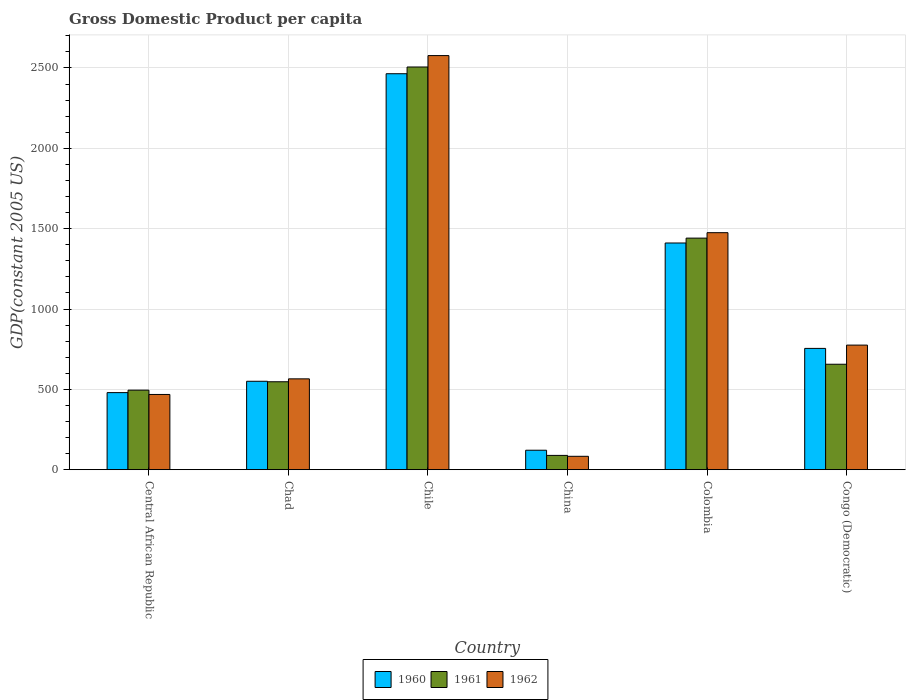How many different coloured bars are there?
Provide a succinct answer. 3. How many groups of bars are there?
Ensure brevity in your answer.  6. Are the number of bars per tick equal to the number of legend labels?
Provide a short and direct response. Yes. What is the GDP per capita in 1962 in Chad?
Offer a terse response. 565.29. Across all countries, what is the maximum GDP per capita in 1962?
Ensure brevity in your answer.  2577.05. Across all countries, what is the minimum GDP per capita in 1962?
Provide a short and direct response. 83.33. In which country was the GDP per capita in 1960 minimum?
Your response must be concise. China. What is the total GDP per capita in 1962 in the graph?
Your answer should be compact. 5944.15. What is the difference between the GDP per capita in 1960 in Central African Republic and that in Chad?
Give a very brief answer. -70.54. What is the difference between the GDP per capita in 1961 in Congo (Democratic) and the GDP per capita in 1960 in Central African Republic?
Provide a short and direct response. 176.5. What is the average GDP per capita in 1962 per country?
Keep it short and to the point. 990.69. What is the difference between the GDP per capita of/in 1960 and GDP per capita of/in 1962 in Chile?
Provide a succinct answer. -112.9. What is the ratio of the GDP per capita in 1961 in Central African Republic to that in China?
Provide a short and direct response. 5.56. Is the difference between the GDP per capita in 1960 in Chad and Chile greater than the difference between the GDP per capita in 1962 in Chad and Chile?
Your answer should be compact. Yes. What is the difference between the highest and the second highest GDP per capita in 1962?
Offer a very short reply. 1102.11. What is the difference between the highest and the lowest GDP per capita in 1962?
Give a very brief answer. 2493.72. In how many countries, is the GDP per capita in 1960 greater than the average GDP per capita in 1960 taken over all countries?
Offer a terse response. 2. How many bars are there?
Offer a terse response. 18. What is the difference between two consecutive major ticks on the Y-axis?
Provide a succinct answer. 500. Are the values on the major ticks of Y-axis written in scientific E-notation?
Give a very brief answer. No. How are the legend labels stacked?
Keep it short and to the point. Horizontal. What is the title of the graph?
Give a very brief answer. Gross Domestic Product per capita. Does "1989" appear as one of the legend labels in the graph?
Your answer should be compact. No. What is the label or title of the Y-axis?
Your answer should be compact. GDP(constant 2005 US). What is the GDP(constant 2005 US) in 1960 in Central African Republic?
Provide a succinct answer. 479.7. What is the GDP(constant 2005 US) of 1961 in Central African Republic?
Your response must be concise. 494.99. What is the GDP(constant 2005 US) of 1962 in Central African Republic?
Give a very brief answer. 468.21. What is the GDP(constant 2005 US) in 1960 in Chad?
Provide a succinct answer. 550.24. What is the GDP(constant 2005 US) in 1961 in Chad?
Offer a terse response. 547.21. What is the GDP(constant 2005 US) in 1962 in Chad?
Make the answer very short. 565.29. What is the GDP(constant 2005 US) of 1960 in Chile?
Give a very brief answer. 2464.15. What is the GDP(constant 2005 US) in 1961 in Chile?
Offer a terse response. 2506.04. What is the GDP(constant 2005 US) of 1962 in Chile?
Ensure brevity in your answer.  2577.05. What is the GDP(constant 2005 US) of 1960 in China?
Give a very brief answer. 121.19. What is the GDP(constant 2005 US) in 1961 in China?
Keep it short and to the point. 89.01. What is the GDP(constant 2005 US) in 1962 in China?
Your answer should be compact. 83.33. What is the GDP(constant 2005 US) of 1960 in Colombia?
Give a very brief answer. 1410.75. What is the GDP(constant 2005 US) in 1961 in Colombia?
Offer a very short reply. 1441.14. What is the GDP(constant 2005 US) of 1962 in Colombia?
Offer a very short reply. 1474.94. What is the GDP(constant 2005 US) of 1960 in Congo (Democratic)?
Offer a very short reply. 754.88. What is the GDP(constant 2005 US) of 1961 in Congo (Democratic)?
Make the answer very short. 656.2. What is the GDP(constant 2005 US) in 1962 in Congo (Democratic)?
Offer a very short reply. 775.32. Across all countries, what is the maximum GDP(constant 2005 US) of 1960?
Provide a short and direct response. 2464.15. Across all countries, what is the maximum GDP(constant 2005 US) in 1961?
Provide a short and direct response. 2506.04. Across all countries, what is the maximum GDP(constant 2005 US) in 1962?
Provide a succinct answer. 2577.05. Across all countries, what is the minimum GDP(constant 2005 US) of 1960?
Your answer should be compact. 121.19. Across all countries, what is the minimum GDP(constant 2005 US) of 1961?
Ensure brevity in your answer.  89.01. Across all countries, what is the minimum GDP(constant 2005 US) of 1962?
Make the answer very short. 83.33. What is the total GDP(constant 2005 US) of 1960 in the graph?
Give a very brief answer. 5780.91. What is the total GDP(constant 2005 US) of 1961 in the graph?
Ensure brevity in your answer.  5734.6. What is the total GDP(constant 2005 US) in 1962 in the graph?
Offer a very short reply. 5944.15. What is the difference between the GDP(constant 2005 US) in 1960 in Central African Republic and that in Chad?
Your response must be concise. -70.54. What is the difference between the GDP(constant 2005 US) of 1961 in Central African Republic and that in Chad?
Ensure brevity in your answer.  -52.22. What is the difference between the GDP(constant 2005 US) in 1962 in Central African Republic and that in Chad?
Offer a very short reply. -97.08. What is the difference between the GDP(constant 2005 US) in 1960 in Central African Republic and that in Chile?
Offer a very short reply. -1984.45. What is the difference between the GDP(constant 2005 US) of 1961 in Central African Republic and that in Chile?
Your answer should be very brief. -2011.05. What is the difference between the GDP(constant 2005 US) in 1962 in Central African Republic and that in Chile?
Keep it short and to the point. -2108.84. What is the difference between the GDP(constant 2005 US) in 1960 in Central African Republic and that in China?
Your answer should be compact. 358.51. What is the difference between the GDP(constant 2005 US) of 1961 in Central African Republic and that in China?
Keep it short and to the point. 405.99. What is the difference between the GDP(constant 2005 US) of 1962 in Central African Republic and that in China?
Your answer should be compact. 384.88. What is the difference between the GDP(constant 2005 US) of 1960 in Central African Republic and that in Colombia?
Offer a very short reply. -931.05. What is the difference between the GDP(constant 2005 US) in 1961 in Central African Republic and that in Colombia?
Offer a very short reply. -946.15. What is the difference between the GDP(constant 2005 US) in 1962 in Central African Republic and that in Colombia?
Provide a short and direct response. -1006.73. What is the difference between the GDP(constant 2005 US) of 1960 in Central African Republic and that in Congo (Democratic)?
Ensure brevity in your answer.  -275.18. What is the difference between the GDP(constant 2005 US) in 1961 in Central African Republic and that in Congo (Democratic)?
Offer a very short reply. -161.21. What is the difference between the GDP(constant 2005 US) in 1962 in Central African Republic and that in Congo (Democratic)?
Offer a very short reply. -307.11. What is the difference between the GDP(constant 2005 US) of 1960 in Chad and that in Chile?
Your answer should be compact. -1913.91. What is the difference between the GDP(constant 2005 US) in 1961 in Chad and that in Chile?
Make the answer very short. -1958.84. What is the difference between the GDP(constant 2005 US) in 1962 in Chad and that in Chile?
Provide a succinct answer. -2011.76. What is the difference between the GDP(constant 2005 US) in 1960 in Chad and that in China?
Keep it short and to the point. 429.05. What is the difference between the GDP(constant 2005 US) of 1961 in Chad and that in China?
Your response must be concise. 458.2. What is the difference between the GDP(constant 2005 US) in 1962 in Chad and that in China?
Give a very brief answer. 481.95. What is the difference between the GDP(constant 2005 US) of 1960 in Chad and that in Colombia?
Your answer should be very brief. -860.51. What is the difference between the GDP(constant 2005 US) of 1961 in Chad and that in Colombia?
Your response must be concise. -893.93. What is the difference between the GDP(constant 2005 US) in 1962 in Chad and that in Colombia?
Your answer should be compact. -909.66. What is the difference between the GDP(constant 2005 US) in 1960 in Chad and that in Congo (Democratic)?
Give a very brief answer. -204.64. What is the difference between the GDP(constant 2005 US) in 1961 in Chad and that in Congo (Democratic)?
Give a very brief answer. -108.99. What is the difference between the GDP(constant 2005 US) of 1962 in Chad and that in Congo (Democratic)?
Your answer should be compact. -210.03. What is the difference between the GDP(constant 2005 US) of 1960 in Chile and that in China?
Provide a short and direct response. 2342.96. What is the difference between the GDP(constant 2005 US) of 1961 in Chile and that in China?
Provide a short and direct response. 2417.04. What is the difference between the GDP(constant 2005 US) of 1962 in Chile and that in China?
Make the answer very short. 2493.72. What is the difference between the GDP(constant 2005 US) of 1960 in Chile and that in Colombia?
Your answer should be compact. 1053.4. What is the difference between the GDP(constant 2005 US) of 1961 in Chile and that in Colombia?
Keep it short and to the point. 1064.9. What is the difference between the GDP(constant 2005 US) of 1962 in Chile and that in Colombia?
Keep it short and to the point. 1102.11. What is the difference between the GDP(constant 2005 US) in 1960 in Chile and that in Congo (Democratic)?
Your answer should be compact. 1709.27. What is the difference between the GDP(constant 2005 US) in 1961 in Chile and that in Congo (Democratic)?
Offer a very short reply. 1849.84. What is the difference between the GDP(constant 2005 US) in 1962 in Chile and that in Congo (Democratic)?
Offer a very short reply. 1801.74. What is the difference between the GDP(constant 2005 US) in 1960 in China and that in Colombia?
Offer a terse response. -1289.56. What is the difference between the GDP(constant 2005 US) in 1961 in China and that in Colombia?
Provide a succinct answer. -1352.14. What is the difference between the GDP(constant 2005 US) in 1962 in China and that in Colombia?
Offer a very short reply. -1391.61. What is the difference between the GDP(constant 2005 US) of 1960 in China and that in Congo (Democratic)?
Offer a very short reply. -633.69. What is the difference between the GDP(constant 2005 US) of 1961 in China and that in Congo (Democratic)?
Offer a terse response. -567.2. What is the difference between the GDP(constant 2005 US) in 1962 in China and that in Congo (Democratic)?
Ensure brevity in your answer.  -691.98. What is the difference between the GDP(constant 2005 US) of 1960 in Colombia and that in Congo (Democratic)?
Offer a terse response. 655.87. What is the difference between the GDP(constant 2005 US) of 1961 in Colombia and that in Congo (Democratic)?
Offer a terse response. 784.94. What is the difference between the GDP(constant 2005 US) in 1962 in Colombia and that in Congo (Democratic)?
Your answer should be very brief. 699.63. What is the difference between the GDP(constant 2005 US) of 1960 in Central African Republic and the GDP(constant 2005 US) of 1961 in Chad?
Keep it short and to the point. -67.51. What is the difference between the GDP(constant 2005 US) in 1960 in Central African Republic and the GDP(constant 2005 US) in 1962 in Chad?
Your answer should be very brief. -85.59. What is the difference between the GDP(constant 2005 US) in 1961 in Central African Republic and the GDP(constant 2005 US) in 1962 in Chad?
Your response must be concise. -70.3. What is the difference between the GDP(constant 2005 US) in 1960 in Central African Republic and the GDP(constant 2005 US) in 1961 in Chile?
Ensure brevity in your answer.  -2026.34. What is the difference between the GDP(constant 2005 US) in 1960 in Central African Republic and the GDP(constant 2005 US) in 1962 in Chile?
Your response must be concise. -2097.35. What is the difference between the GDP(constant 2005 US) in 1961 in Central African Republic and the GDP(constant 2005 US) in 1962 in Chile?
Your answer should be very brief. -2082.06. What is the difference between the GDP(constant 2005 US) in 1960 in Central African Republic and the GDP(constant 2005 US) in 1961 in China?
Make the answer very short. 390.69. What is the difference between the GDP(constant 2005 US) of 1960 in Central African Republic and the GDP(constant 2005 US) of 1962 in China?
Provide a short and direct response. 396.37. What is the difference between the GDP(constant 2005 US) of 1961 in Central African Republic and the GDP(constant 2005 US) of 1962 in China?
Your response must be concise. 411.66. What is the difference between the GDP(constant 2005 US) of 1960 in Central African Republic and the GDP(constant 2005 US) of 1961 in Colombia?
Your answer should be very brief. -961.44. What is the difference between the GDP(constant 2005 US) in 1960 in Central African Republic and the GDP(constant 2005 US) in 1962 in Colombia?
Ensure brevity in your answer.  -995.24. What is the difference between the GDP(constant 2005 US) in 1961 in Central African Republic and the GDP(constant 2005 US) in 1962 in Colombia?
Make the answer very short. -979.95. What is the difference between the GDP(constant 2005 US) in 1960 in Central African Republic and the GDP(constant 2005 US) in 1961 in Congo (Democratic)?
Your response must be concise. -176.5. What is the difference between the GDP(constant 2005 US) in 1960 in Central African Republic and the GDP(constant 2005 US) in 1962 in Congo (Democratic)?
Offer a terse response. -295.62. What is the difference between the GDP(constant 2005 US) in 1961 in Central African Republic and the GDP(constant 2005 US) in 1962 in Congo (Democratic)?
Your response must be concise. -280.33. What is the difference between the GDP(constant 2005 US) in 1960 in Chad and the GDP(constant 2005 US) in 1961 in Chile?
Make the answer very short. -1955.81. What is the difference between the GDP(constant 2005 US) in 1960 in Chad and the GDP(constant 2005 US) in 1962 in Chile?
Your answer should be very brief. -2026.81. What is the difference between the GDP(constant 2005 US) in 1961 in Chad and the GDP(constant 2005 US) in 1962 in Chile?
Offer a very short reply. -2029.84. What is the difference between the GDP(constant 2005 US) of 1960 in Chad and the GDP(constant 2005 US) of 1961 in China?
Provide a short and direct response. 461.23. What is the difference between the GDP(constant 2005 US) of 1960 in Chad and the GDP(constant 2005 US) of 1962 in China?
Offer a terse response. 466.9. What is the difference between the GDP(constant 2005 US) of 1961 in Chad and the GDP(constant 2005 US) of 1962 in China?
Ensure brevity in your answer.  463.88. What is the difference between the GDP(constant 2005 US) of 1960 in Chad and the GDP(constant 2005 US) of 1961 in Colombia?
Keep it short and to the point. -890.9. What is the difference between the GDP(constant 2005 US) of 1960 in Chad and the GDP(constant 2005 US) of 1962 in Colombia?
Offer a very short reply. -924.71. What is the difference between the GDP(constant 2005 US) of 1961 in Chad and the GDP(constant 2005 US) of 1962 in Colombia?
Keep it short and to the point. -927.74. What is the difference between the GDP(constant 2005 US) of 1960 in Chad and the GDP(constant 2005 US) of 1961 in Congo (Democratic)?
Keep it short and to the point. -105.96. What is the difference between the GDP(constant 2005 US) in 1960 in Chad and the GDP(constant 2005 US) in 1962 in Congo (Democratic)?
Make the answer very short. -225.08. What is the difference between the GDP(constant 2005 US) of 1961 in Chad and the GDP(constant 2005 US) of 1962 in Congo (Democratic)?
Ensure brevity in your answer.  -228.11. What is the difference between the GDP(constant 2005 US) in 1960 in Chile and the GDP(constant 2005 US) in 1961 in China?
Your answer should be compact. 2375.15. What is the difference between the GDP(constant 2005 US) of 1960 in Chile and the GDP(constant 2005 US) of 1962 in China?
Your answer should be compact. 2380.82. What is the difference between the GDP(constant 2005 US) of 1961 in Chile and the GDP(constant 2005 US) of 1962 in China?
Offer a very short reply. 2422.71. What is the difference between the GDP(constant 2005 US) of 1960 in Chile and the GDP(constant 2005 US) of 1961 in Colombia?
Provide a succinct answer. 1023.01. What is the difference between the GDP(constant 2005 US) in 1960 in Chile and the GDP(constant 2005 US) in 1962 in Colombia?
Offer a very short reply. 989.21. What is the difference between the GDP(constant 2005 US) of 1961 in Chile and the GDP(constant 2005 US) of 1962 in Colombia?
Offer a very short reply. 1031.1. What is the difference between the GDP(constant 2005 US) in 1960 in Chile and the GDP(constant 2005 US) in 1961 in Congo (Democratic)?
Your answer should be compact. 1807.95. What is the difference between the GDP(constant 2005 US) in 1960 in Chile and the GDP(constant 2005 US) in 1962 in Congo (Democratic)?
Give a very brief answer. 1688.83. What is the difference between the GDP(constant 2005 US) of 1961 in Chile and the GDP(constant 2005 US) of 1962 in Congo (Democratic)?
Make the answer very short. 1730.73. What is the difference between the GDP(constant 2005 US) in 1960 in China and the GDP(constant 2005 US) in 1961 in Colombia?
Provide a short and direct response. -1319.95. What is the difference between the GDP(constant 2005 US) in 1960 in China and the GDP(constant 2005 US) in 1962 in Colombia?
Offer a very short reply. -1353.75. What is the difference between the GDP(constant 2005 US) of 1961 in China and the GDP(constant 2005 US) of 1962 in Colombia?
Offer a terse response. -1385.94. What is the difference between the GDP(constant 2005 US) in 1960 in China and the GDP(constant 2005 US) in 1961 in Congo (Democratic)?
Your answer should be compact. -535.01. What is the difference between the GDP(constant 2005 US) in 1960 in China and the GDP(constant 2005 US) in 1962 in Congo (Democratic)?
Your response must be concise. -654.13. What is the difference between the GDP(constant 2005 US) in 1961 in China and the GDP(constant 2005 US) in 1962 in Congo (Democratic)?
Make the answer very short. -686.31. What is the difference between the GDP(constant 2005 US) of 1960 in Colombia and the GDP(constant 2005 US) of 1961 in Congo (Democratic)?
Offer a terse response. 754.55. What is the difference between the GDP(constant 2005 US) in 1960 in Colombia and the GDP(constant 2005 US) in 1962 in Congo (Democratic)?
Offer a very short reply. 635.43. What is the difference between the GDP(constant 2005 US) of 1961 in Colombia and the GDP(constant 2005 US) of 1962 in Congo (Democratic)?
Ensure brevity in your answer.  665.82. What is the average GDP(constant 2005 US) in 1960 per country?
Give a very brief answer. 963.49. What is the average GDP(constant 2005 US) of 1961 per country?
Your response must be concise. 955.77. What is the average GDP(constant 2005 US) of 1962 per country?
Provide a short and direct response. 990.69. What is the difference between the GDP(constant 2005 US) of 1960 and GDP(constant 2005 US) of 1961 in Central African Republic?
Your answer should be very brief. -15.29. What is the difference between the GDP(constant 2005 US) of 1960 and GDP(constant 2005 US) of 1962 in Central African Republic?
Provide a succinct answer. 11.49. What is the difference between the GDP(constant 2005 US) of 1961 and GDP(constant 2005 US) of 1962 in Central African Republic?
Give a very brief answer. 26.78. What is the difference between the GDP(constant 2005 US) of 1960 and GDP(constant 2005 US) of 1961 in Chad?
Make the answer very short. 3.03. What is the difference between the GDP(constant 2005 US) in 1960 and GDP(constant 2005 US) in 1962 in Chad?
Keep it short and to the point. -15.05. What is the difference between the GDP(constant 2005 US) of 1961 and GDP(constant 2005 US) of 1962 in Chad?
Your response must be concise. -18.08. What is the difference between the GDP(constant 2005 US) in 1960 and GDP(constant 2005 US) in 1961 in Chile?
Make the answer very short. -41.89. What is the difference between the GDP(constant 2005 US) of 1960 and GDP(constant 2005 US) of 1962 in Chile?
Provide a succinct answer. -112.9. What is the difference between the GDP(constant 2005 US) of 1961 and GDP(constant 2005 US) of 1962 in Chile?
Give a very brief answer. -71.01. What is the difference between the GDP(constant 2005 US) in 1960 and GDP(constant 2005 US) in 1961 in China?
Provide a short and direct response. 32.19. What is the difference between the GDP(constant 2005 US) of 1960 and GDP(constant 2005 US) of 1962 in China?
Provide a succinct answer. 37.86. What is the difference between the GDP(constant 2005 US) of 1961 and GDP(constant 2005 US) of 1962 in China?
Your response must be concise. 5.67. What is the difference between the GDP(constant 2005 US) in 1960 and GDP(constant 2005 US) in 1961 in Colombia?
Offer a very short reply. -30.39. What is the difference between the GDP(constant 2005 US) of 1960 and GDP(constant 2005 US) of 1962 in Colombia?
Make the answer very short. -64.19. What is the difference between the GDP(constant 2005 US) of 1961 and GDP(constant 2005 US) of 1962 in Colombia?
Provide a succinct answer. -33.8. What is the difference between the GDP(constant 2005 US) in 1960 and GDP(constant 2005 US) in 1961 in Congo (Democratic)?
Offer a very short reply. 98.68. What is the difference between the GDP(constant 2005 US) of 1960 and GDP(constant 2005 US) of 1962 in Congo (Democratic)?
Your response must be concise. -20.44. What is the difference between the GDP(constant 2005 US) of 1961 and GDP(constant 2005 US) of 1962 in Congo (Democratic)?
Your answer should be very brief. -119.11. What is the ratio of the GDP(constant 2005 US) of 1960 in Central African Republic to that in Chad?
Ensure brevity in your answer.  0.87. What is the ratio of the GDP(constant 2005 US) in 1961 in Central African Republic to that in Chad?
Make the answer very short. 0.9. What is the ratio of the GDP(constant 2005 US) of 1962 in Central African Republic to that in Chad?
Your answer should be very brief. 0.83. What is the ratio of the GDP(constant 2005 US) in 1960 in Central African Republic to that in Chile?
Provide a short and direct response. 0.19. What is the ratio of the GDP(constant 2005 US) of 1961 in Central African Republic to that in Chile?
Make the answer very short. 0.2. What is the ratio of the GDP(constant 2005 US) of 1962 in Central African Republic to that in Chile?
Offer a very short reply. 0.18. What is the ratio of the GDP(constant 2005 US) in 1960 in Central African Republic to that in China?
Provide a succinct answer. 3.96. What is the ratio of the GDP(constant 2005 US) in 1961 in Central African Republic to that in China?
Your response must be concise. 5.56. What is the ratio of the GDP(constant 2005 US) in 1962 in Central African Republic to that in China?
Keep it short and to the point. 5.62. What is the ratio of the GDP(constant 2005 US) of 1960 in Central African Republic to that in Colombia?
Ensure brevity in your answer.  0.34. What is the ratio of the GDP(constant 2005 US) in 1961 in Central African Republic to that in Colombia?
Make the answer very short. 0.34. What is the ratio of the GDP(constant 2005 US) in 1962 in Central African Republic to that in Colombia?
Keep it short and to the point. 0.32. What is the ratio of the GDP(constant 2005 US) of 1960 in Central African Republic to that in Congo (Democratic)?
Ensure brevity in your answer.  0.64. What is the ratio of the GDP(constant 2005 US) of 1961 in Central African Republic to that in Congo (Democratic)?
Ensure brevity in your answer.  0.75. What is the ratio of the GDP(constant 2005 US) of 1962 in Central African Republic to that in Congo (Democratic)?
Ensure brevity in your answer.  0.6. What is the ratio of the GDP(constant 2005 US) of 1960 in Chad to that in Chile?
Make the answer very short. 0.22. What is the ratio of the GDP(constant 2005 US) of 1961 in Chad to that in Chile?
Your response must be concise. 0.22. What is the ratio of the GDP(constant 2005 US) in 1962 in Chad to that in Chile?
Ensure brevity in your answer.  0.22. What is the ratio of the GDP(constant 2005 US) in 1960 in Chad to that in China?
Ensure brevity in your answer.  4.54. What is the ratio of the GDP(constant 2005 US) of 1961 in Chad to that in China?
Provide a succinct answer. 6.15. What is the ratio of the GDP(constant 2005 US) in 1962 in Chad to that in China?
Your answer should be compact. 6.78. What is the ratio of the GDP(constant 2005 US) in 1960 in Chad to that in Colombia?
Provide a succinct answer. 0.39. What is the ratio of the GDP(constant 2005 US) of 1961 in Chad to that in Colombia?
Ensure brevity in your answer.  0.38. What is the ratio of the GDP(constant 2005 US) of 1962 in Chad to that in Colombia?
Provide a short and direct response. 0.38. What is the ratio of the GDP(constant 2005 US) in 1960 in Chad to that in Congo (Democratic)?
Offer a very short reply. 0.73. What is the ratio of the GDP(constant 2005 US) of 1961 in Chad to that in Congo (Democratic)?
Keep it short and to the point. 0.83. What is the ratio of the GDP(constant 2005 US) of 1962 in Chad to that in Congo (Democratic)?
Provide a short and direct response. 0.73. What is the ratio of the GDP(constant 2005 US) of 1960 in Chile to that in China?
Your answer should be very brief. 20.33. What is the ratio of the GDP(constant 2005 US) in 1961 in Chile to that in China?
Ensure brevity in your answer.  28.16. What is the ratio of the GDP(constant 2005 US) of 1962 in Chile to that in China?
Your response must be concise. 30.92. What is the ratio of the GDP(constant 2005 US) of 1960 in Chile to that in Colombia?
Give a very brief answer. 1.75. What is the ratio of the GDP(constant 2005 US) of 1961 in Chile to that in Colombia?
Your response must be concise. 1.74. What is the ratio of the GDP(constant 2005 US) in 1962 in Chile to that in Colombia?
Ensure brevity in your answer.  1.75. What is the ratio of the GDP(constant 2005 US) of 1960 in Chile to that in Congo (Democratic)?
Your answer should be very brief. 3.26. What is the ratio of the GDP(constant 2005 US) of 1961 in Chile to that in Congo (Democratic)?
Give a very brief answer. 3.82. What is the ratio of the GDP(constant 2005 US) of 1962 in Chile to that in Congo (Democratic)?
Your answer should be very brief. 3.32. What is the ratio of the GDP(constant 2005 US) of 1960 in China to that in Colombia?
Your response must be concise. 0.09. What is the ratio of the GDP(constant 2005 US) in 1961 in China to that in Colombia?
Make the answer very short. 0.06. What is the ratio of the GDP(constant 2005 US) of 1962 in China to that in Colombia?
Your response must be concise. 0.06. What is the ratio of the GDP(constant 2005 US) in 1960 in China to that in Congo (Democratic)?
Provide a succinct answer. 0.16. What is the ratio of the GDP(constant 2005 US) of 1961 in China to that in Congo (Democratic)?
Provide a succinct answer. 0.14. What is the ratio of the GDP(constant 2005 US) in 1962 in China to that in Congo (Democratic)?
Give a very brief answer. 0.11. What is the ratio of the GDP(constant 2005 US) in 1960 in Colombia to that in Congo (Democratic)?
Offer a terse response. 1.87. What is the ratio of the GDP(constant 2005 US) of 1961 in Colombia to that in Congo (Democratic)?
Ensure brevity in your answer.  2.2. What is the ratio of the GDP(constant 2005 US) of 1962 in Colombia to that in Congo (Democratic)?
Make the answer very short. 1.9. What is the difference between the highest and the second highest GDP(constant 2005 US) in 1960?
Ensure brevity in your answer.  1053.4. What is the difference between the highest and the second highest GDP(constant 2005 US) in 1961?
Provide a short and direct response. 1064.9. What is the difference between the highest and the second highest GDP(constant 2005 US) of 1962?
Your response must be concise. 1102.11. What is the difference between the highest and the lowest GDP(constant 2005 US) of 1960?
Your response must be concise. 2342.96. What is the difference between the highest and the lowest GDP(constant 2005 US) in 1961?
Offer a very short reply. 2417.04. What is the difference between the highest and the lowest GDP(constant 2005 US) of 1962?
Provide a short and direct response. 2493.72. 